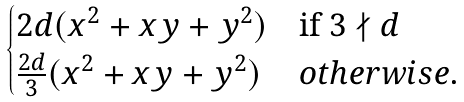Convert formula to latex. <formula><loc_0><loc_0><loc_500><loc_500>\begin{cases} 2 d ( x ^ { 2 } + x y + y ^ { 2 } ) & \text {if $3\nmid d$} \\ \frac { 2 d } { 3 } ( x ^ { 2 } + x y + y ^ { 2 } ) & o t h e r w i s e . \end{cases}</formula> 